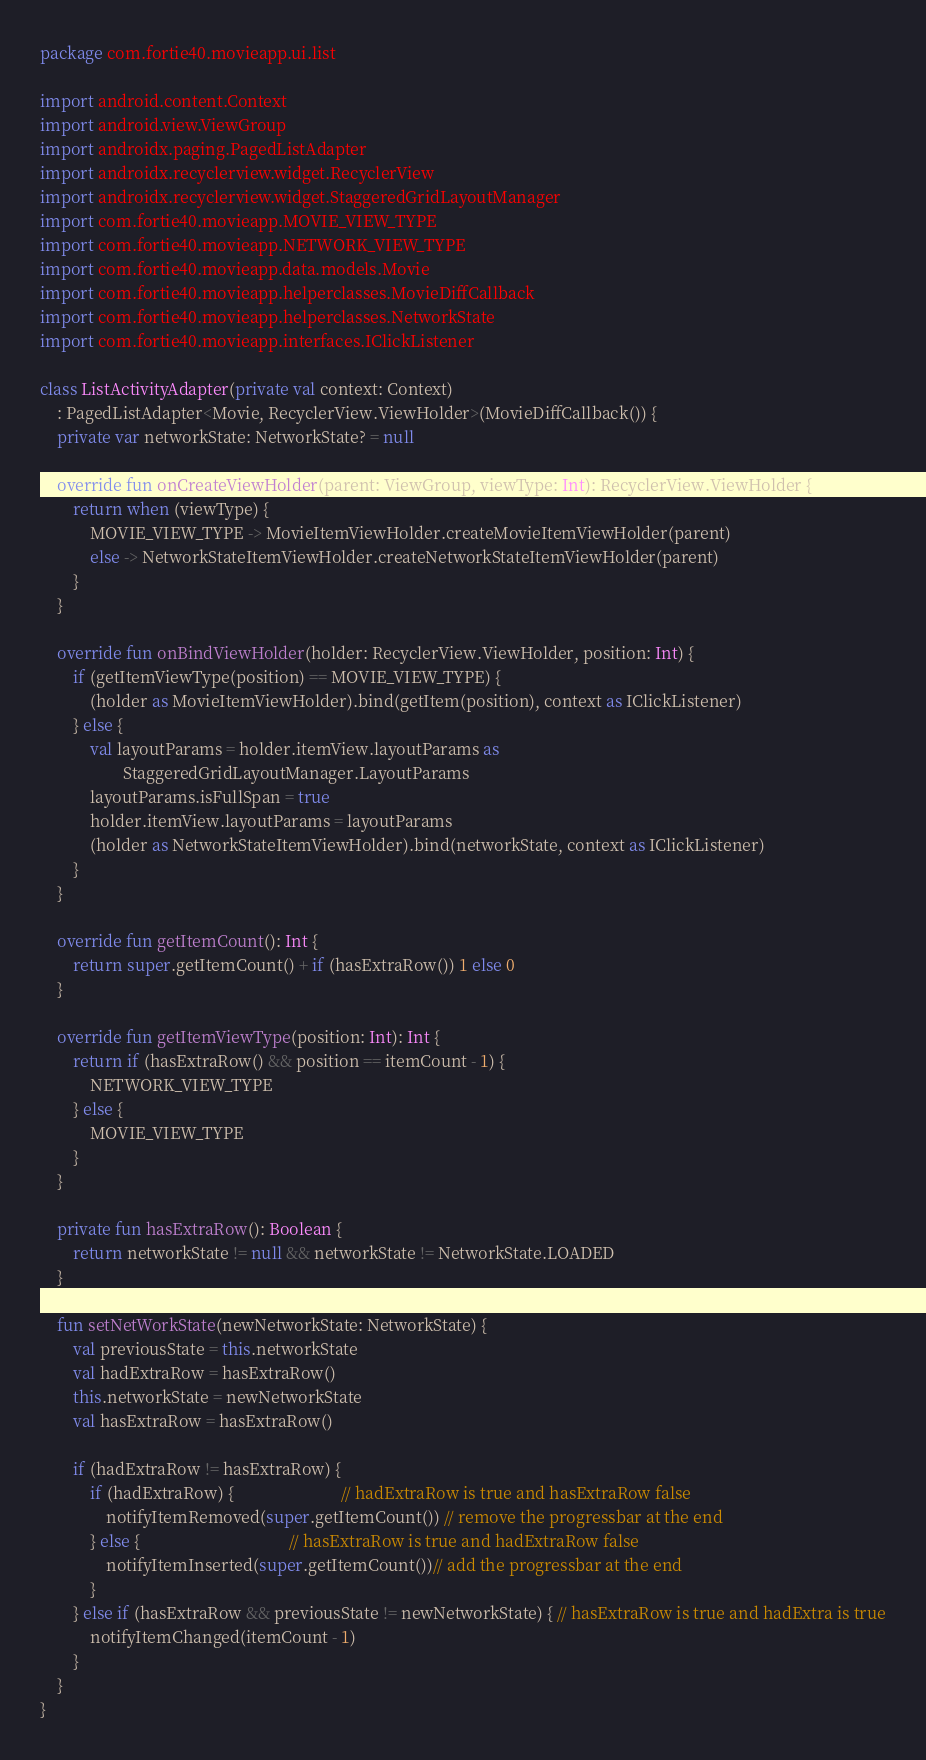<code> <loc_0><loc_0><loc_500><loc_500><_Kotlin_>package com.fortie40.movieapp.ui.list

import android.content.Context
import android.view.ViewGroup
import androidx.paging.PagedListAdapter
import androidx.recyclerview.widget.RecyclerView
import androidx.recyclerview.widget.StaggeredGridLayoutManager
import com.fortie40.movieapp.MOVIE_VIEW_TYPE
import com.fortie40.movieapp.NETWORK_VIEW_TYPE
import com.fortie40.movieapp.data.models.Movie
import com.fortie40.movieapp.helperclasses.MovieDiffCallback
import com.fortie40.movieapp.helperclasses.NetworkState
import com.fortie40.movieapp.interfaces.IClickListener

class ListActivityAdapter(private val context: Context)
    : PagedListAdapter<Movie, RecyclerView.ViewHolder>(MovieDiffCallback()) {
    private var networkState: NetworkState? = null

    override fun onCreateViewHolder(parent: ViewGroup, viewType: Int): RecyclerView.ViewHolder {
        return when (viewType) {
            MOVIE_VIEW_TYPE -> MovieItemViewHolder.createMovieItemViewHolder(parent)
            else -> NetworkStateItemViewHolder.createNetworkStateItemViewHolder(parent)
        }
    }

    override fun onBindViewHolder(holder: RecyclerView.ViewHolder, position: Int) {
        if (getItemViewType(position) == MOVIE_VIEW_TYPE) {
            (holder as MovieItemViewHolder).bind(getItem(position), context as IClickListener)
        } else {
            val layoutParams = holder.itemView.layoutParams as
                    StaggeredGridLayoutManager.LayoutParams
            layoutParams.isFullSpan = true
            holder.itemView.layoutParams = layoutParams
            (holder as NetworkStateItemViewHolder).bind(networkState, context as IClickListener)
        }
    }

    override fun getItemCount(): Int {
        return super.getItemCount() + if (hasExtraRow()) 1 else 0
    }

    override fun getItemViewType(position: Int): Int {
        return if (hasExtraRow() && position == itemCount - 1) {
            NETWORK_VIEW_TYPE
        } else {
            MOVIE_VIEW_TYPE
        }
    }

    private fun hasExtraRow(): Boolean {
        return networkState != null && networkState != NetworkState.LOADED
    }

    fun setNetWorkState(newNetworkState: NetworkState) {
        val previousState = this.networkState
        val hadExtraRow = hasExtraRow()
        this.networkState = newNetworkState
        val hasExtraRow = hasExtraRow()

        if (hadExtraRow != hasExtraRow) {
            if (hadExtraRow) {                          // hadExtraRow is true and hasExtraRow false
                notifyItemRemoved(super.getItemCount()) // remove the progressbar at the end
            } else {                                    // hasExtraRow is true and hadExtraRow false
                notifyItemInserted(super.getItemCount())// add the progressbar at the end
            }
        } else if (hasExtraRow && previousState != newNetworkState) { // hasExtraRow is true and hadExtra is true
            notifyItemChanged(itemCount - 1)
        }
    }
}</code> 